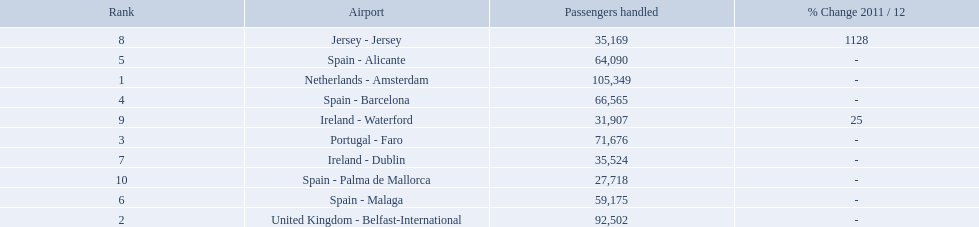Which airports had passengers going through london southend airport? Netherlands - Amsterdam, United Kingdom - Belfast-International, Portugal - Faro, Spain - Barcelona, Spain - Alicante, Spain - Malaga, Ireland - Dublin, Jersey - Jersey, Ireland - Waterford, Spain - Palma de Mallorca. Of those airports, which airport had the least amount of passengers going through london southend airport? Spain - Palma de Mallorca. 